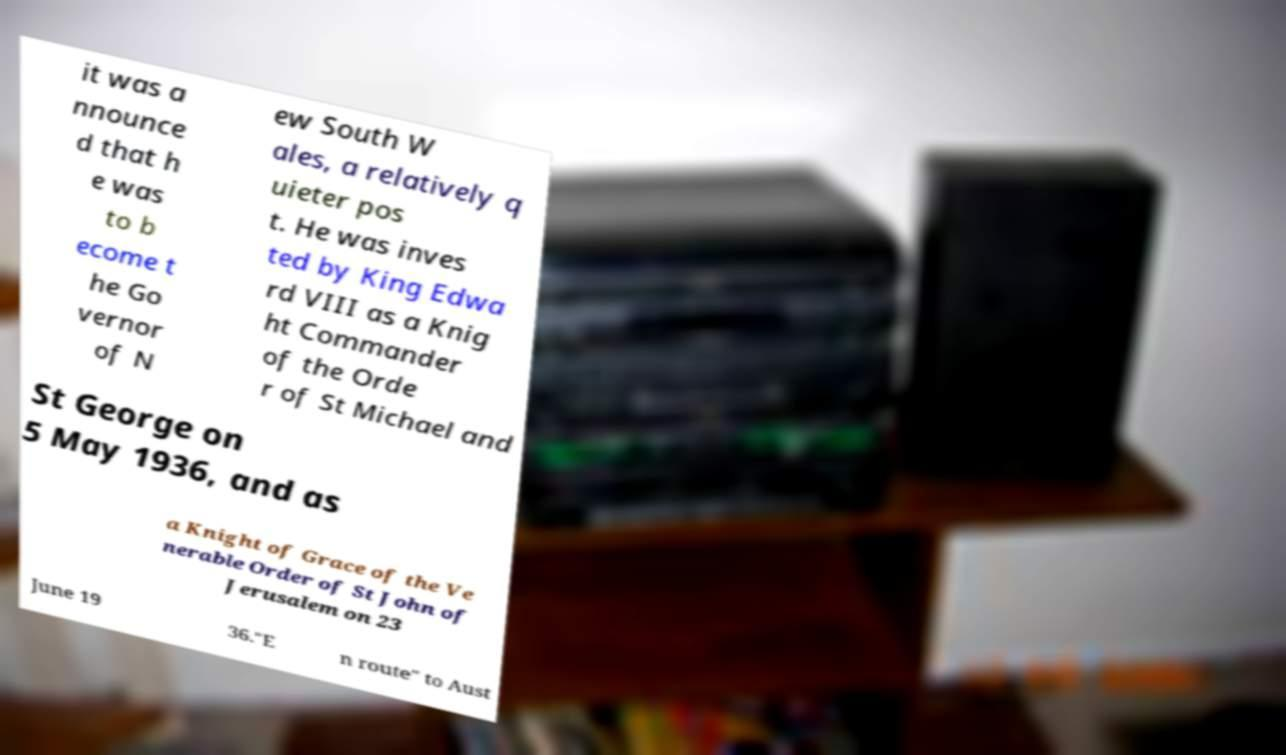Please read and relay the text visible in this image. What does it say? it was a nnounce d that h e was to b ecome t he Go vernor of N ew South W ales, a relatively q uieter pos t. He was inves ted by King Edwa rd VIII as a Knig ht Commander of the Orde r of St Michael and St George on 5 May 1936, and as a Knight of Grace of the Ve nerable Order of St John of Jerusalem on 23 June 19 36."E n route" to Aust 